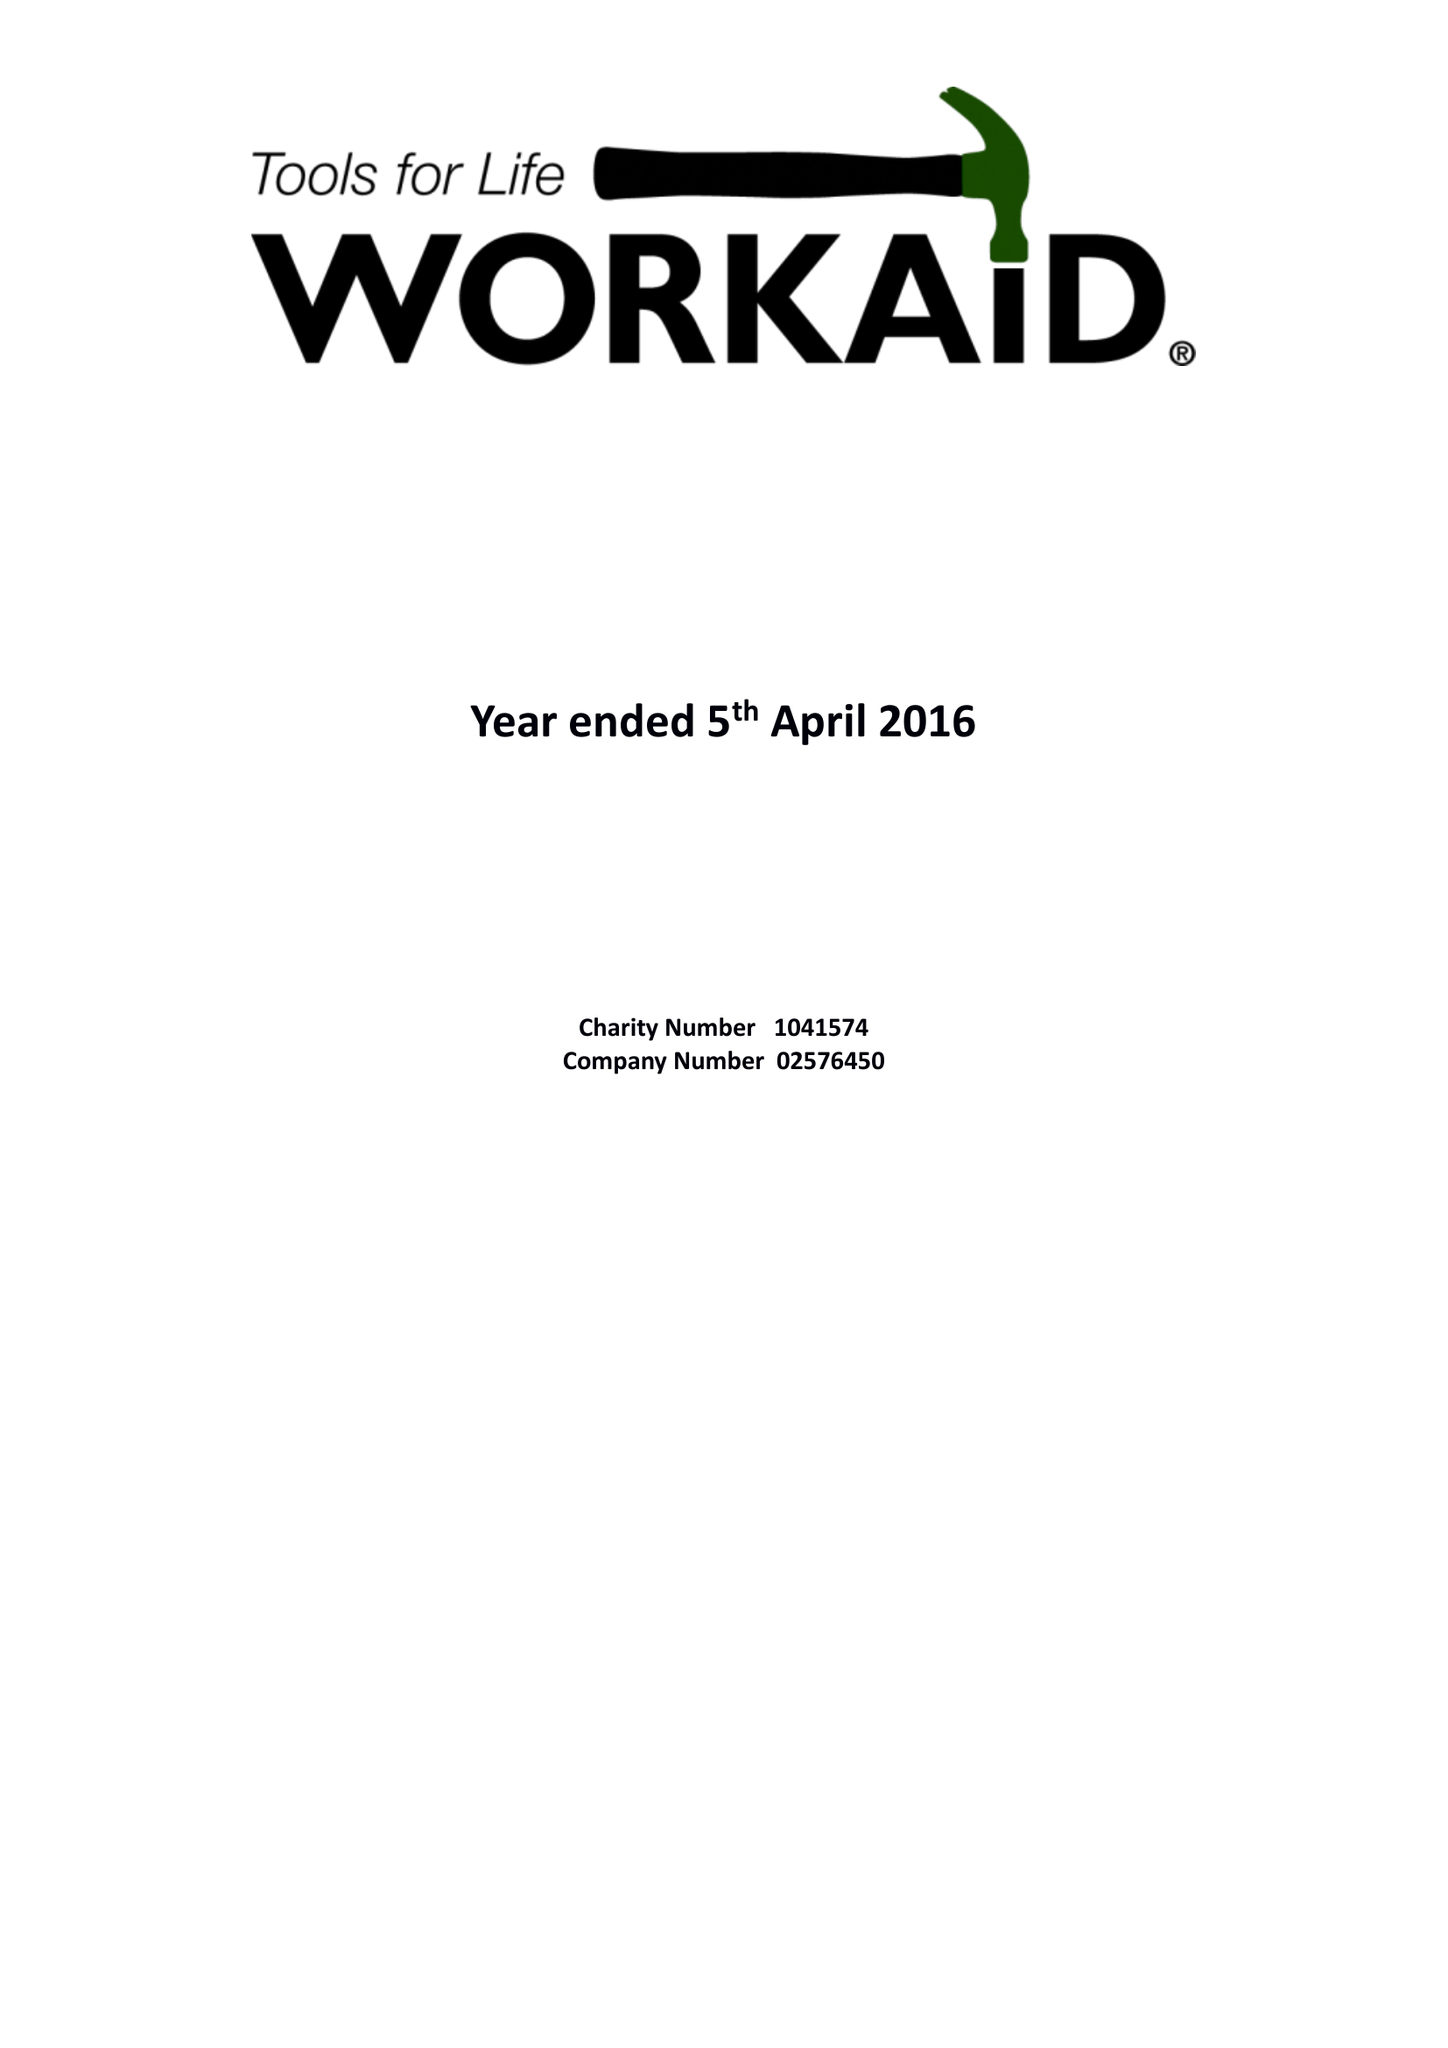What is the value for the report_date?
Answer the question using a single word or phrase. 2016-04-05 